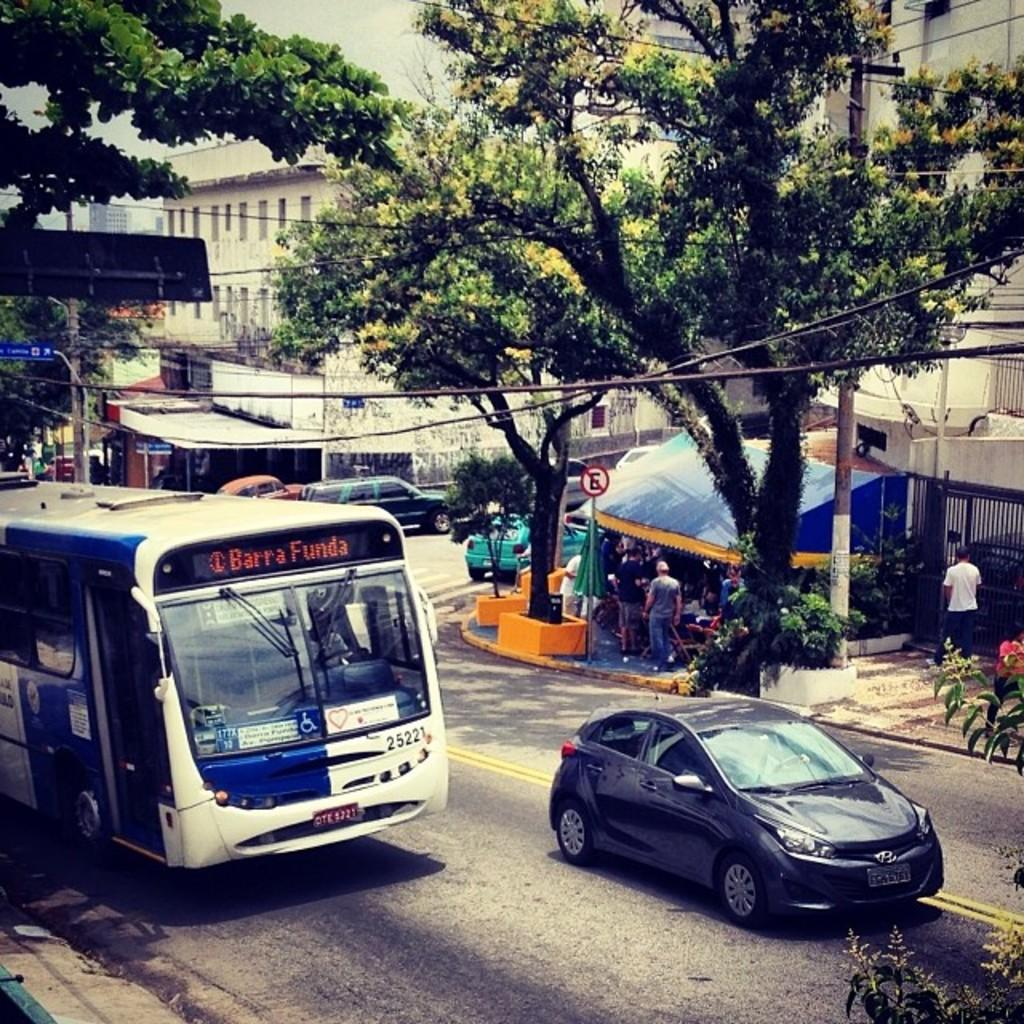What can be seen on the road in the image? There are vehicles on the road in the image. What type of natural elements can be seen in the image? Trees are visible in the image. What type of man-made structures are present in the image? Signboards, poles, buildings, and a tent are present in the image. Who or what is visible in the image? People are visible in the image. What activity might be taking place in the image? There is a grill beside a person in the image, suggesting that they might be cooking or grilling food. Can you see a monkey swinging from the trees in the image? No, there is no monkey present in the image. What type of mist can be seen in the image? There is no mist visible in the image. What type of destruction can be seen in the image? There is no destruction present in the image. 